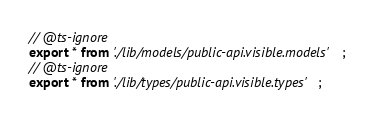Convert code to text. <code><loc_0><loc_0><loc_500><loc_500><_TypeScript_>
// @ts-ignore
export * from './lib/models/public-api.visible.models';
// @ts-ignore
export * from './lib/types/public-api.visible.types';
</code> 